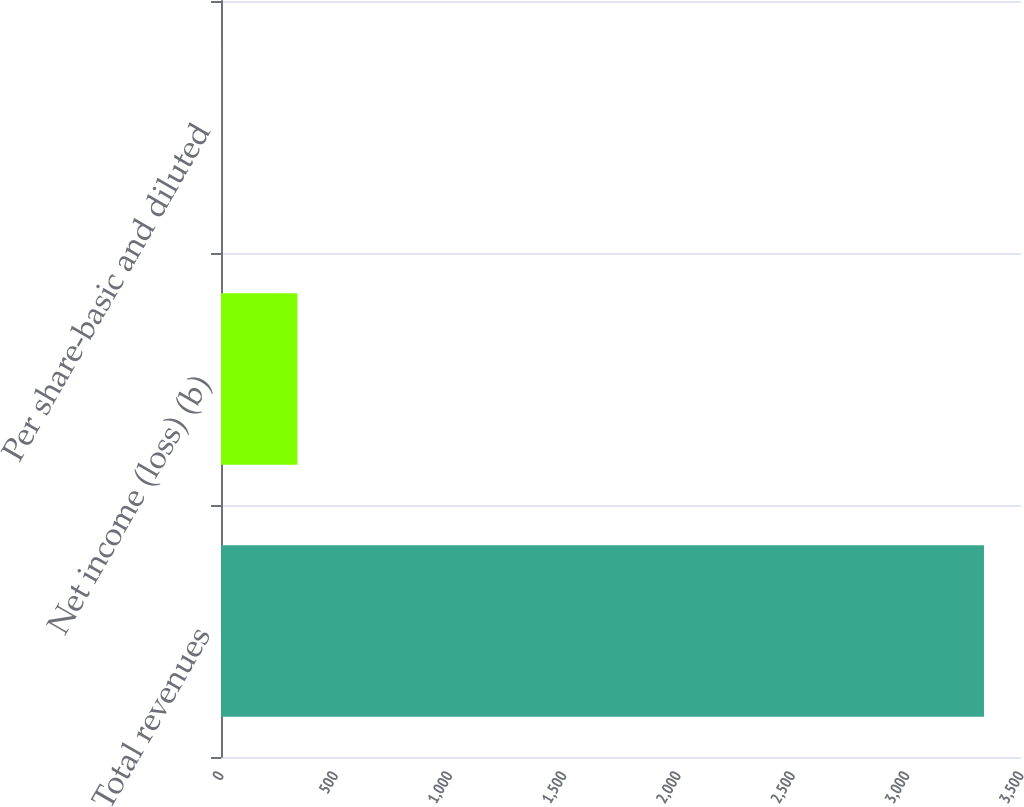Convert chart to OTSL. <chart><loc_0><loc_0><loc_500><loc_500><bar_chart><fcel>Total revenues<fcel>Net income (loss) (b)<fcel>Per share-basic and diluted<nl><fcel>3338<fcel>334.32<fcel>0.58<nl></chart> 